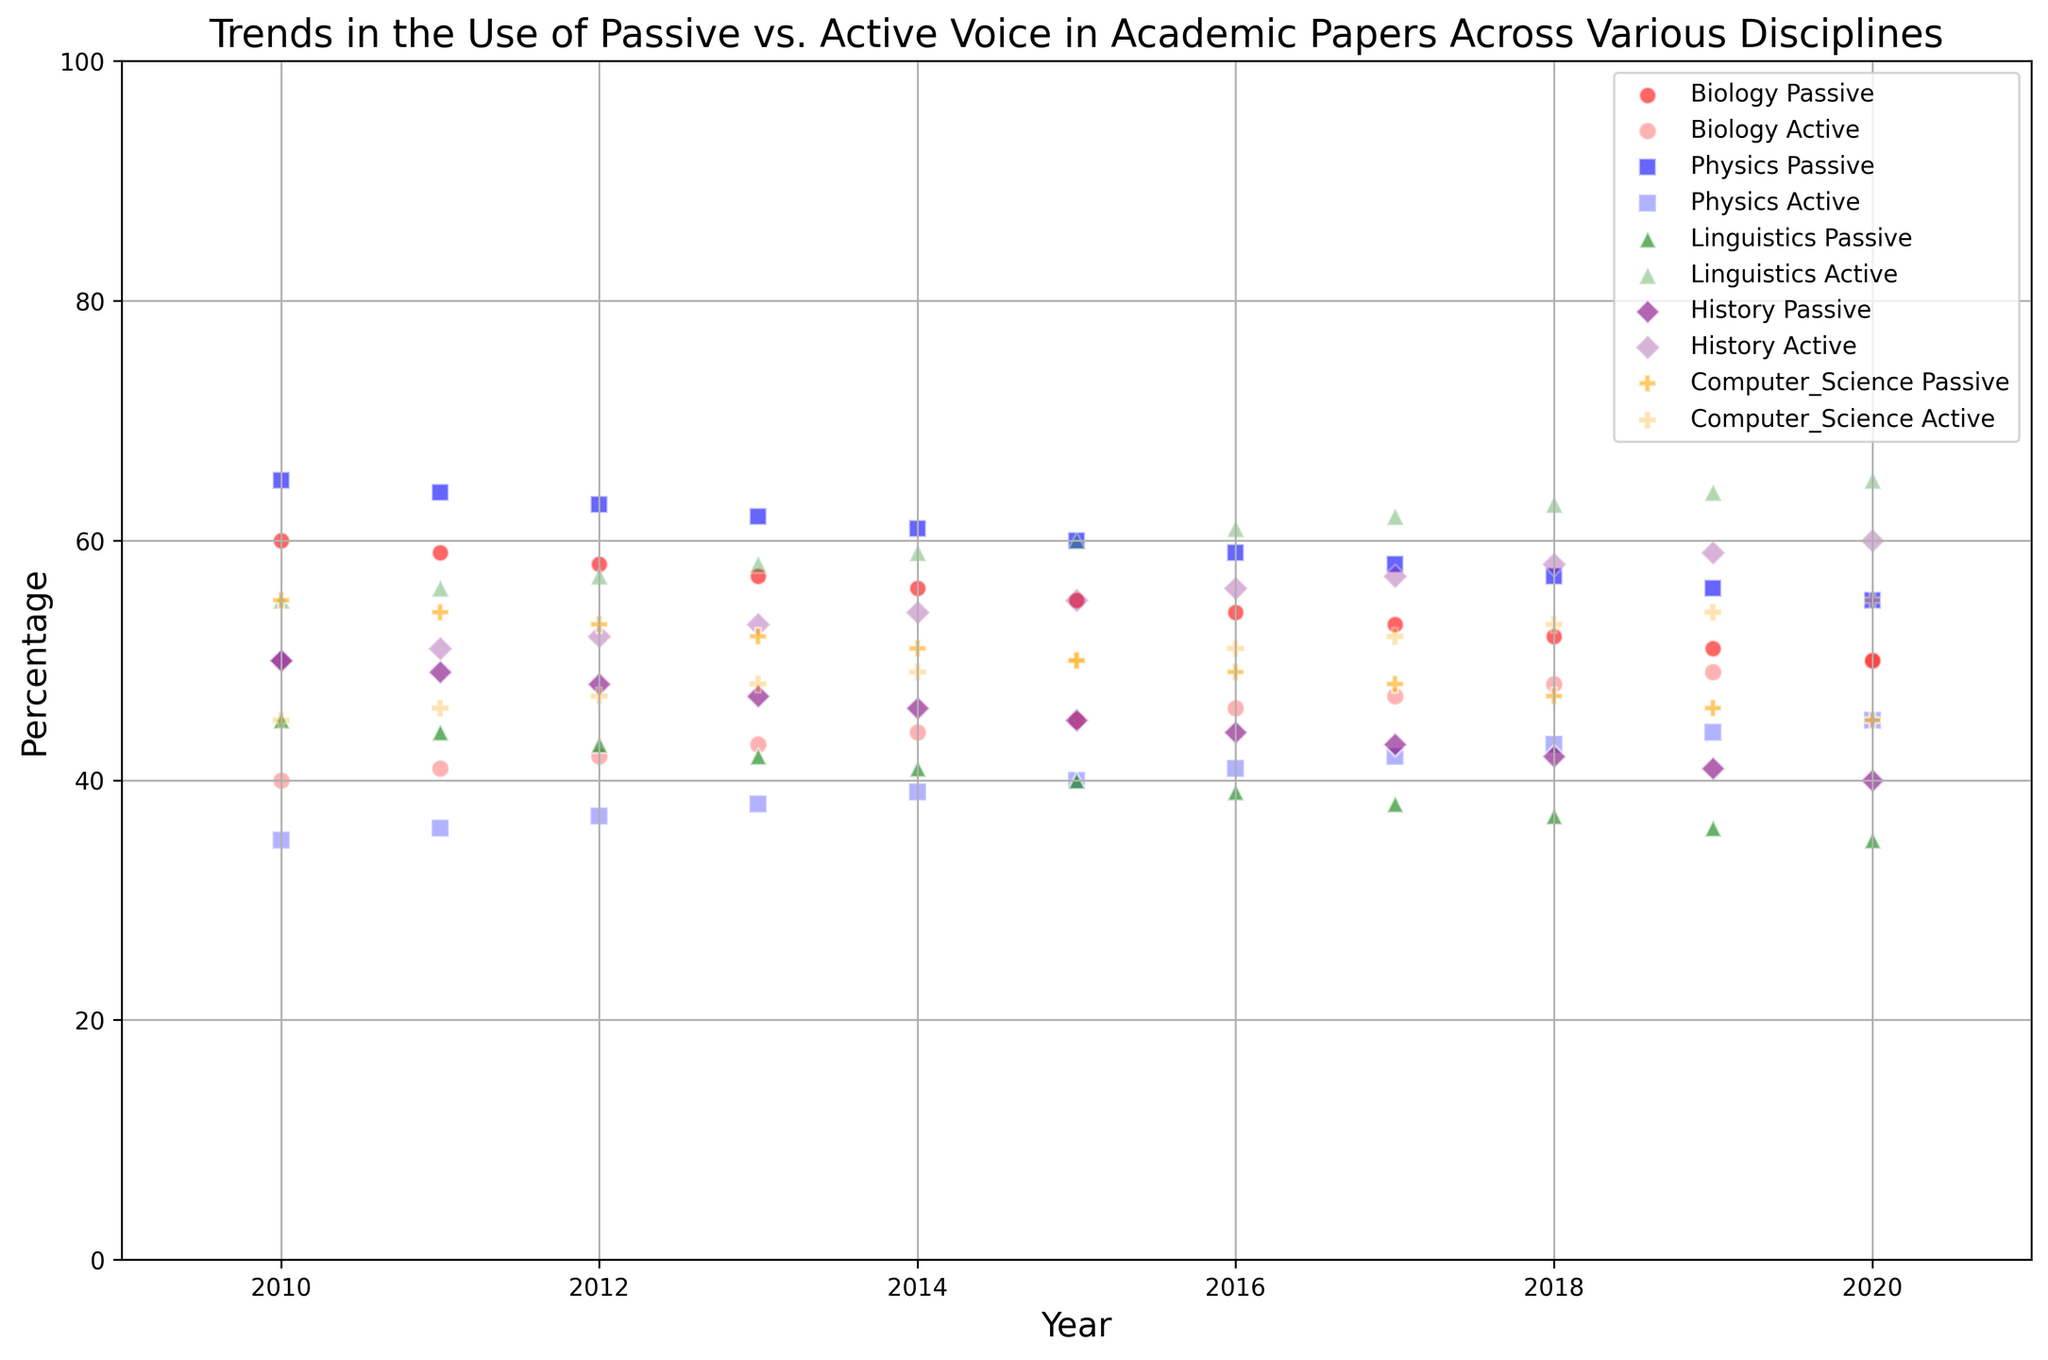Which discipline had the highest percentage of passive voice usage in 2010? To find the discipline with the highest percentage of passive voice usage in 2010, locate the data points for 2010 and compare the y-values (representing percentage). The highest y-value for 2010 is Physics at 65%.
Answer: Physics Which year did Biology papers have equal percentages of passive and active voice? To find the year when Biology had equal percentages of passive and active voice, look for the intersection point where the passive and active percentages are both 50%. For Biology, this occurs in 2020.
Answer: 2020 How much did the percentage of passive voice in Linguistics decrease from 2010 to 2020? To calculate the decrease, subtract the percentage of passive voice in 2020 from that in 2010 for Linguistics. The values are 45% in 2010 and 35% in 2020, so the decrease is 45% - 35% = 10%.
Answer: 10% In which discipline did the percentage of active voice surpass 60% first? To determine the first instance of active voice surpassing 60% in any discipline, identify the point where the green (Linguistics) crossed this threshold in 2013.
Answer: Linguistics Compare the rate of decrease in passive voice usage between Biology and Physics over the decade. Which one shows a sharper decline? Calculate the decrease for both: Biology from 60% (2010) to 50% (2020) is 10% and Physics from 65% (2010) to 55% (2020) is also 10%. The rate of decrease is similar (1% per year). Thus, neither shows a sharper decline.
Answer: Similar What is the average percentage of active voice usage in Computer Science from 2010 to 2020? Sum the active percentages for Computer Science over the years and divide by the number of years (2010-2020). These are 45, 46, 47, 48, 49, 50, 51, 52, 53, 54, 55, so the average is (45+46+47+48+49+50+51+52+53+54+55)/11 = 50%.
Answer: 50% Which discipline had a greater percentage change in passive voice usage from 2010 to 2020, History or Computer Science? Calculate the percentage change for both disciplines: History from 50% to 40% is 10% change; Computer Science from 55% to 45% is also a 10% change. Both have the same percentage change.
Answer: Equal In which year did Physics achieve a passive voice percentage equivalent to Biology's in 2013? Look at Biology's passive percentage in 2013, which is 57%. Find the year in Physics with a corresponding percentage, which is 2015.
Answer: 2015 How do the trends in passive voice usage in History and Linguistics compare? Examine the slopes of the lines in History and Linguistics. Both decline, but History's line is less steep, indicating a slower rate of decline compared to Linguistics over the years.
Answer: Linguistics declines faster In 2019, which disciplines show a similar percentage usage of passive voice? Observe the data points for passive voice in 2019. Both Biology with 51% and Computer Science with 46% are not close enough; compare Physics at 56% and History at 41%, and Linguistics at 36%. Only Biology (51%) and Computer Science (46%) are closer, though still apart by 5%.
Answer: None similar 